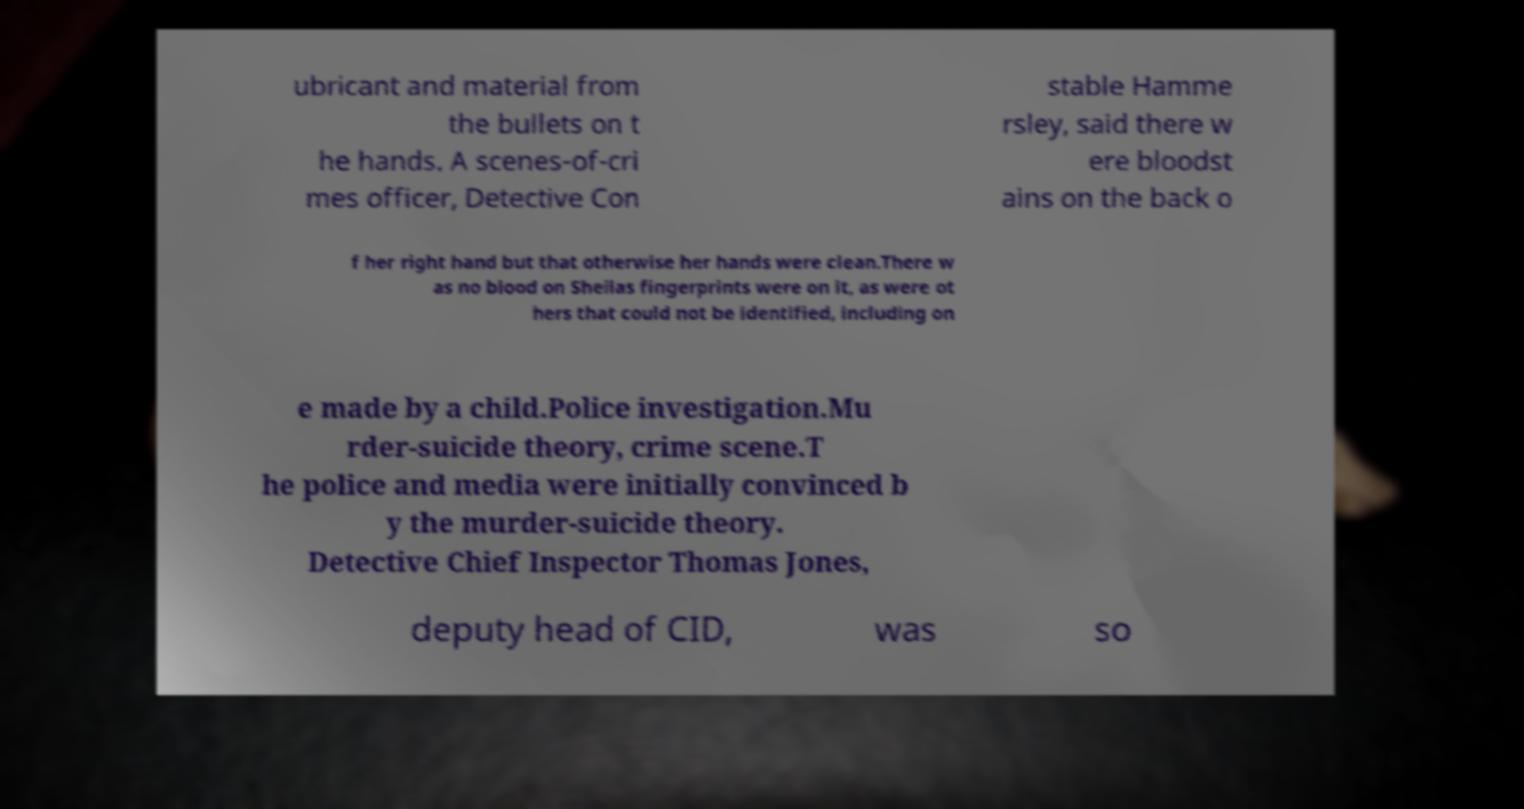Please identify and transcribe the text found in this image. ubricant and material from the bullets on t he hands. A scenes-of-cri mes officer, Detective Con stable Hamme rsley, said there w ere bloodst ains on the back o f her right hand but that otherwise her hands were clean.There w as no blood on Sheilas fingerprints were on it, as were ot hers that could not be identified, including on e made by a child.Police investigation.Mu rder-suicide theory, crime scene.T he police and media were initially convinced b y the murder-suicide theory. Detective Chief Inspector Thomas Jones, deputy head of CID, was so 